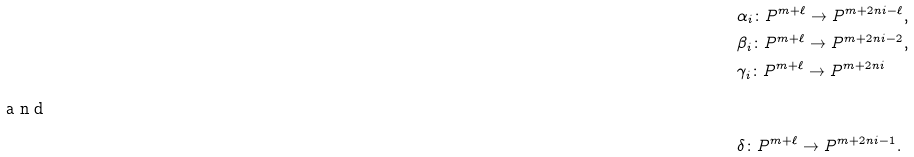Convert formula to latex. <formula><loc_0><loc_0><loc_500><loc_500>& \alpha _ { i } \colon P ^ { m + \ell } \to P ^ { m + 2 n i - \ell } , \\ & \beta _ { i } \colon P ^ { m + \ell } \to P ^ { m + 2 n i - 2 } , \\ & \gamma _ { i } \colon P ^ { m + \ell } \to P ^ { m + 2 n i } \\ \intertext { a n d } & \delta \colon P ^ { m + \ell } \to P ^ { m + 2 n i - 1 } .</formula> 